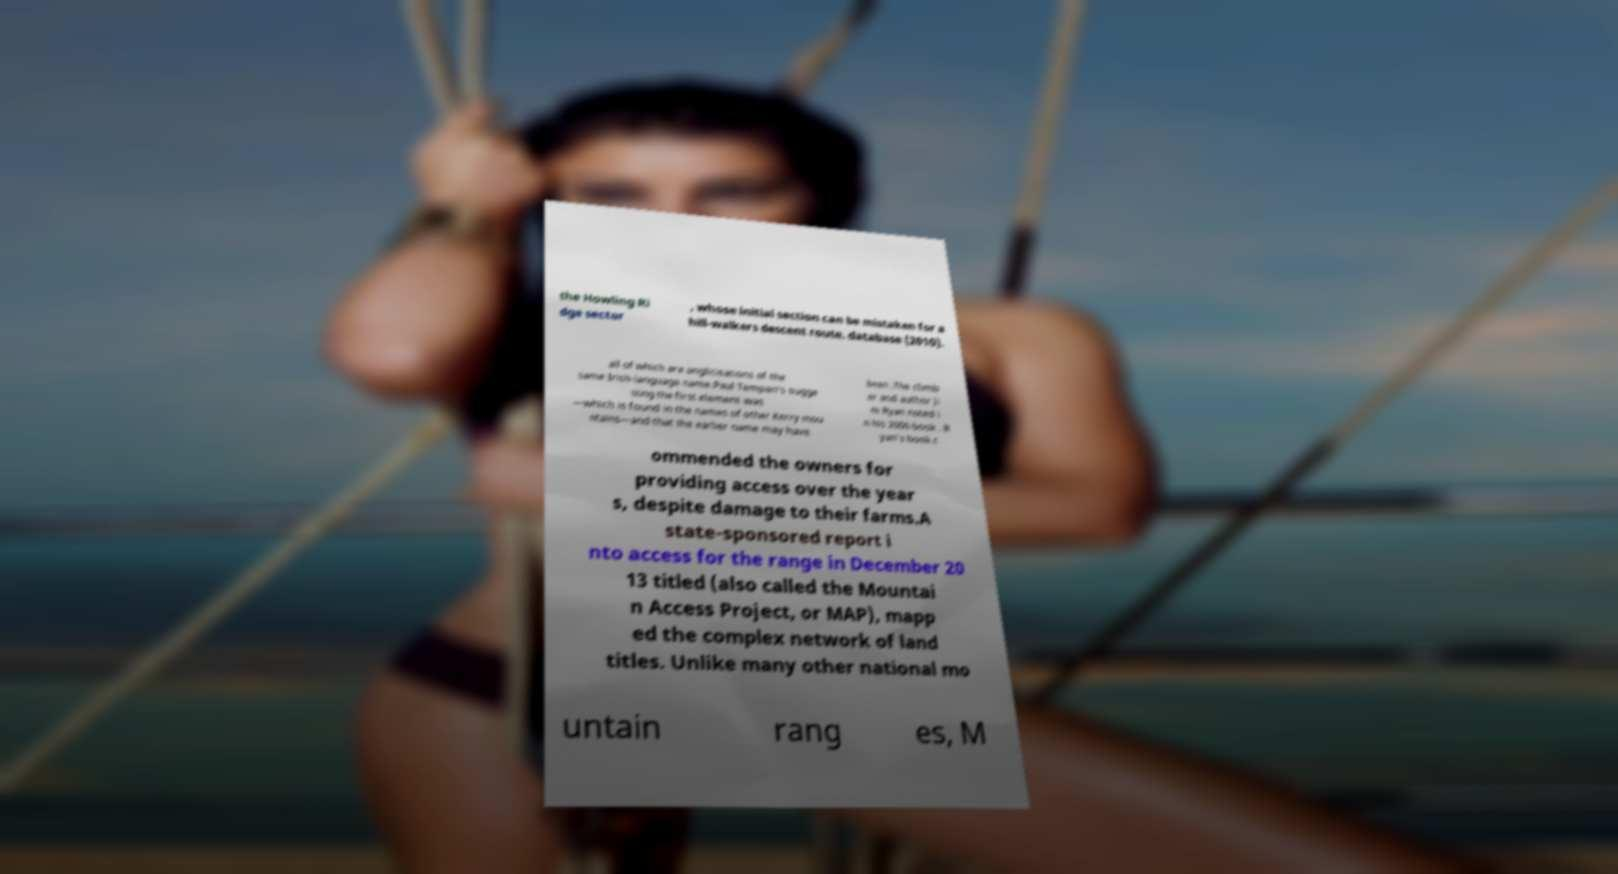There's text embedded in this image that I need extracted. Can you transcribe it verbatim? the Howling Ri dge sector , whose initial section can be mistaken for a hill-walkers descent route. database (2010). all of which are anglicisations of the same Irish-language name.Paul Tempan's sugge sting the first element was —which is found in the names of other Kerry mou ntains—and that the earlier name may have been .The climb er and author Ji m Ryan noted i n his 2006 book . R yan's book c ommended the owners for providing access over the year s, despite damage to their farms.A state-sponsored report i nto access for the range in December 20 13 titled (also called the Mountai n Access Project, or MAP), mapp ed the complex network of land titles. Unlike many other national mo untain rang es, M 